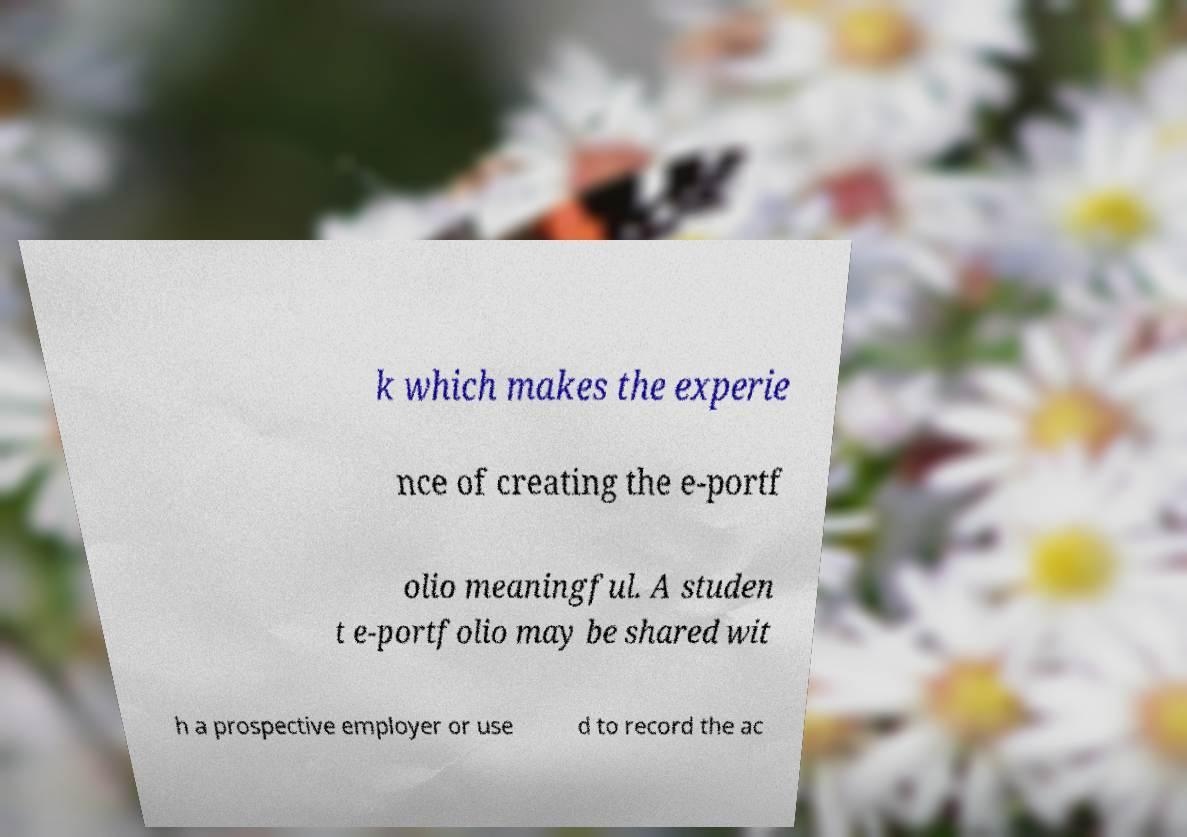Please identify and transcribe the text found in this image. k which makes the experie nce of creating the e-portf olio meaningful. A studen t e-portfolio may be shared wit h a prospective employer or use d to record the ac 